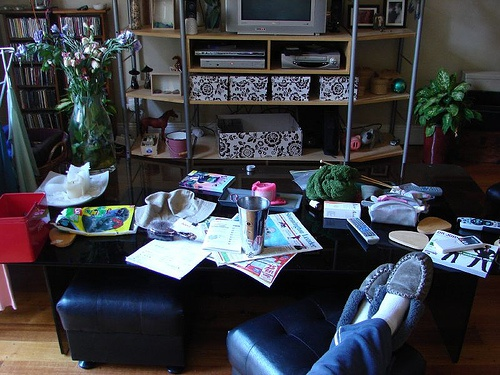Describe the objects in this image and their specific colors. I can see people in black, navy, gray, and blue tones, couch in black, navy, blue, and darkblue tones, potted plant in black, gray, teal, and darkgreen tones, potted plant in black, darkgreen, and teal tones, and tv in black and gray tones in this image. 